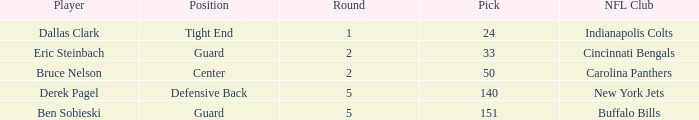What was the latest round that Derek Pagel was selected with a pick higher than 50? 5.0. 